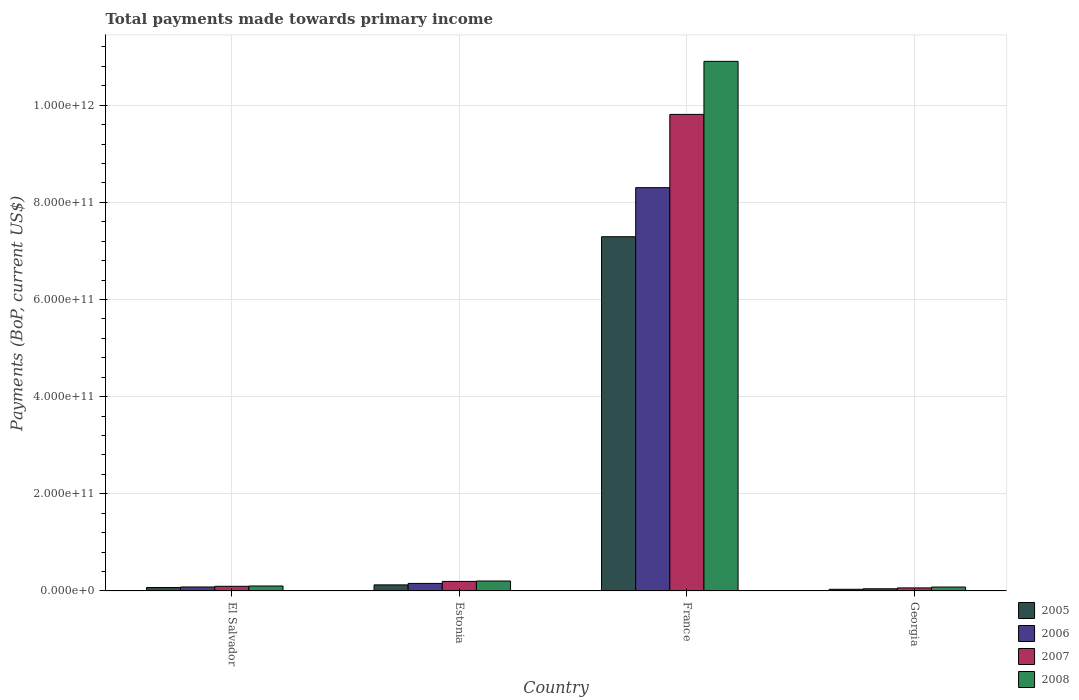How many bars are there on the 1st tick from the left?
Provide a succinct answer. 4. How many bars are there on the 3rd tick from the right?
Ensure brevity in your answer.  4. What is the label of the 4th group of bars from the left?
Your answer should be very brief. Georgia. In how many cases, is the number of bars for a given country not equal to the number of legend labels?
Offer a terse response. 0. What is the total payments made towards primary income in 2007 in France?
Your response must be concise. 9.81e+11. Across all countries, what is the maximum total payments made towards primary income in 2007?
Provide a short and direct response. 9.81e+11. Across all countries, what is the minimum total payments made towards primary income in 2008?
Give a very brief answer. 8.11e+09. In which country was the total payments made towards primary income in 2007 minimum?
Give a very brief answer. Georgia. What is the total total payments made towards primary income in 2006 in the graph?
Your response must be concise. 8.59e+11. What is the difference between the total payments made towards primary income in 2008 in El Salvador and that in Georgia?
Your answer should be compact. 2.15e+09. What is the difference between the total payments made towards primary income in 2005 in Estonia and the total payments made towards primary income in 2007 in El Salvador?
Ensure brevity in your answer.  2.93e+09. What is the average total payments made towards primary income in 2006 per country?
Your answer should be very brief. 2.15e+11. What is the difference between the total payments made towards primary income of/in 2007 and total payments made towards primary income of/in 2006 in Estonia?
Ensure brevity in your answer.  4.11e+09. What is the ratio of the total payments made towards primary income in 2006 in El Salvador to that in Georgia?
Provide a succinct answer. 1.81. Is the total payments made towards primary income in 2005 in Estonia less than that in Georgia?
Provide a succinct answer. No. What is the difference between the highest and the second highest total payments made towards primary income in 2008?
Keep it short and to the point. 1.07e+12. What is the difference between the highest and the lowest total payments made towards primary income in 2005?
Give a very brief answer. 7.26e+11. In how many countries, is the total payments made towards primary income in 2008 greater than the average total payments made towards primary income in 2008 taken over all countries?
Provide a short and direct response. 1. What does the 2nd bar from the left in Estonia represents?
Your answer should be very brief. 2006. Is it the case that in every country, the sum of the total payments made towards primary income in 2005 and total payments made towards primary income in 2007 is greater than the total payments made towards primary income in 2006?
Your answer should be compact. Yes. How many bars are there?
Make the answer very short. 16. Are all the bars in the graph horizontal?
Make the answer very short. No. What is the difference between two consecutive major ticks on the Y-axis?
Offer a very short reply. 2.00e+11. Are the values on the major ticks of Y-axis written in scientific E-notation?
Your answer should be very brief. Yes. Does the graph contain any zero values?
Your answer should be compact. No. Does the graph contain grids?
Offer a terse response. Yes. Where does the legend appear in the graph?
Keep it short and to the point. Bottom right. How many legend labels are there?
Make the answer very short. 4. How are the legend labels stacked?
Offer a terse response. Vertical. What is the title of the graph?
Keep it short and to the point. Total payments made towards primary income. What is the label or title of the Y-axis?
Provide a succinct answer. Payments (BoP, current US$). What is the Payments (BoP, current US$) of 2005 in El Salvador?
Provide a succinct answer. 7.17e+09. What is the Payments (BoP, current US$) in 2006 in El Salvador?
Give a very brief answer. 8.24e+09. What is the Payments (BoP, current US$) in 2007 in El Salvador?
Provide a short and direct response. 9.62e+09. What is the Payments (BoP, current US$) of 2008 in El Salvador?
Offer a very short reply. 1.03e+1. What is the Payments (BoP, current US$) in 2005 in Estonia?
Offer a very short reply. 1.25e+1. What is the Payments (BoP, current US$) of 2006 in Estonia?
Make the answer very short. 1.56e+1. What is the Payments (BoP, current US$) of 2007 in Estonia?
Your answer should be very brief. 1.97e+1. What is the Payments (BoP, current US$) in 2008 in Estonia?
Offer a very short reply. 2.05e+1. What is the Payments (BoP, current US$) in 2005 in France?
Keep it short and to the point. 7.29e+11. What is the Payments (BoP, current US$) of 2006 in France?
Offer a terse response. 8.30e+11. What is the Payments (BoP, current US$) of 2007 in France?
Your response must be concise. 9.81e+11. What is the Payments (BoP, current US$) of 2008 in France?
Provide a succinct answer. 1.09e+12. What is the Payments (BoP, current US$) of 2005 in Georgia?
Your answer should be very brief. 3.47e+09. What is the Payments (BoP, current US$) in 2006 in Georgia?
Make the answer very short. 4.56e+09. What is the Payments (BoP, current US$) of 2007 in Georgia?
Your answer should be very brief. 6.32e+09. What is the Payments (BoP, current US$) of 2008 in Georgia?
Offer a very short reply. 8.11e+09. Across all countries, what is the maximum Payments (BoP, current US$) of 2005?
Make the answer very short. 7.29e+11. Across all countries, what is the maximum Payments (BoP, current US$) of 2006?
Offer a very short reply. 8.30e+11. Across all countries, what is the maximum Payments (BoP, current US$) in 2007?
Ensure brevity in your answer.  9.81e+11. Across all countries, what is the maximum Payments (BoP, current US$) of 2008?
Make the answer very short. 1.09e+12. Across all countries, what is the minimum Payments (BoP, current US$) of 2005?
Your response must be concise. 3.47e+09. Across all countries, what is the minimum Payments (BoP, current US$) in 2006?
Your response must be concise. 4.56e+09. Across all countries, what is the minimum Payments (BoP, current US$) of 2007?
Make the answer very short. 6.32e+09. Across all countries, what is the minimum Payments (BoP, current US$) in 2008?
Ensure brevity in your answer.  8.11e+09. What is the total Payments (BoP, current US$) of 2005 in the graph?
Your response must be concise. 7.53e+11. What is the total Payments (BoP, current US$) of 2006 in the graph?
Your response must be concise. 8.59e+11. What is the total Payments (BoP, current US$) of 2007 in the graph?
Give a very brief answer. 1.02e+12. What is the total Payments (BoP, current US$) of 2008 in the graph?
Offer a terse response. 1.13e+12. What is the difference between the Payments (BoP, current US$) of 2005 in El Salvador and that in Estonia?
Your answer should be compact. -5.38e+09. What is the difference between the Payments (BoP, current US$) in 2006 in El Salvador and that in Estonia?
Ensure brevity in your answer.  -7.33e+09. What is the difference between the Payments (BoP, current US$) in 2007 in El Salvador and that in Estonia?
Your answer should be compact. -1.01e+1. What is the difference between the Payments (BoP, current US$) of 2008 in El Salvador and that in Estonia?
Your answer should be very brief. -1.03e+1. What is the difference between the Payments (BoP, current US$) of 2005 in El Salvador and that in France?
Offer a terse response. -7.22e+11. What is the difference between the Payments (BoP, current US$) in 2006 in El Salvador and that in France?
Your answer should be compact. -8.22e+11. What is the difference between the Payments (BoP, current US$) in 2007 in El Salvador and that in France?
Provide a short and direct response. -9.72e+11. What is the difference between the Payments (BoP, current US$) of 2008 in El Salvador and that in France?
Offer a terse response. -1.08e+12. What is the difference between the Payments (BoP, current US$) of 2005 in El Salvador and that in Georgia?
Offer a very short reply. 3.70e+09. What is the difference between the Payments (BoP, current US$) in 2006 in El Salvador and that in Georgia?
Make the answer very short. 3.69e+09. What is the difference between the Payments (BoP, current US$) of 2007 in El Salvador and that in Georgia?
Offer a terse response. 3.29e+09. What is the difference between the Payments (BoP, current US$) in 2008 in El Salvador and that in Georgia?
Provide a succinct answer. 2.15e+09. What is the difference between the Payments (BoP, current US$) in 2005 in Estonia and that in France?
Provide a short and direct response. -7.17e+11. What is the difference between the Payments (BoP, current US$) of 2006 in Estonia and that in France?
Your answer should be compact. -8.15e+11. What is the difference between the Payments (BoP, current US$) in 2007 in Estonia and that in France?
Provide a short and direct response. -9.61e+11. What is the difference between the Payments (BoP, current US$) of 2008 in Estonia and that in France?
Your answer should be compact. -1.07e+12. What is the difference between the Payments (BoP, current US$) of 2005 in Estonia and that in Georgia?
Your answer should be compact. 9.08e+09. What is the difference between the Payments (BoP, current US$) in 2006 in Estonia and that in Georgia?
Make the answer very short. 1.10e+1. What is the difference between the Payments (BoP, current US$) of 2007 in Estonia and that in Georgia?
Make the answer very short. 1.34e+1. What is the difference between the Payments (BoP, current US$) in 2008 in Estonia and that in Georgia?
Your answer should be very brief. 1.24e+1. What is the difference between the Payments (BoP, current US$) of 2005 in France and that in Georgia?
Give a very brief answer. 7.26e+11. What is the difference between the Payments (BoP, current US$) in 2006 in France and that in Georgia?
Your answer should be very brief. 8.26e+11. What is the difference between the Payments (BoP, current US$) of 2007 in France and that in Georgia?
Your answer should be compact. 9.75e+11. What is the difference between the Payments (BoP, current US$) in 2008 in France and that in Georgia?
Ensure brevity in your answer.  1.08e+12. What is the difference between the Payments (BoP, current US$) of 2005 in El Salvador and the Payments (BoP, current US$) of 2006 in Estonia?
Keep it short and to the point. -8.40e+09. What is the difference between the Payments (BoP, current US$) of 2005 in El Salvador and the Payments (BoP, current US$) of 2007 in Estonia?
Make the answer very short. -1.25e+1. What is the difference between the Payments (BoP, current US$) of 2005 in El Salvador and the Payments (BoP, current US$) of 2008 in Estonia?
Make the answer very short. -1.34e+1. What is the difference between the Payments (BoP, current US$) in 2006 in El Salvador and the Payments (BoP, current US$) in 2007 in Estonia?
Offer a very short reply. -1.14e+1. What is the difference between the Payments (BoP, current US$) of 2006 in El Salvador and the Payments (BoP, current US$) of 2008 in Estonia?
Offer a terse response. -1.23e+1. What is the difference between the Payments (BoP, current US$) of 2007 in El Salvador and the Payments (BoP, current US$) of 2008 in Estonia?
Make the answer very short. -1.09e+1. What is the difference between the Payments (BoP, current US$) of 2005 in El Salvador and the Payments (BoP, current US$) of 2006 in France?
Give a very brief answer. -8.23e+11. What is the difference between the Payments (BoP, current US$) in 2005 in El Salvador and the Payments (BoP, current US$) in 2007 in France?
Ensure brevity in your answer.  -9.74e+11. What is the difference between the Payments (BoP, current US$) in 2005 in El Salvador and the Payments (BoP, current US$) in 2008 in France?
Offer a very short reply. -1.08e+12. What is the difference between the Payments (BoP, current US$) of 2006 in El Salvador and the Payments (BoP, current US$) of 2007 in France?
Give a very brief answer. -9.73e+11. What is the difference between the Payments (BoP, current US$) of 2006 in El Salvador and the Payments (BoP, current US$) of 2008 in France?
Keep it short and to the point. -1.08e+12. What is the difference between the Payments (BoP, current US$) in 2007 in El Salvador and the Payments (BoP, current US$) in 2008 in France?
Keep it short and to the point. -1.08e+12. What is the difference between the Payments (BoP, current US$) in 2005 in El Salvador and the Payments (BoP, current US$) in 2006 in Georgia?
Provide a short and direct response. 2.62e+09. What is the difference between the Payments (BoP, current US$) of 2005 in El Salvador and the Payments (BoP, current US$) of 2007 in Georgia?
Ensure brevity in your answer.  8.48e+08. What is the difference between the Payments (BoP, current US$) of 2005 in El Salvador and the Payments (BoP, current US$) of 2008 in Georgia?
Offer a very short reply. -9.42e+08. What is the difference between the Payments (BoP, current US$) in 2006 in El Salvador and the Payments (BoP, current US$) in 2007 in Georgia?
Provide a succinct answer. 1.92e+09. What is the difference between the Payments (BoP, current US$) in 2006 in El Salvador and the Payments (BoP, current US$) in 2008 in Georgia?
Give a very brief answer. 1.28e+08. What is the difference between the Payments (BoP, current US$) in 2007 in El Salvador and the Payments (BoP, current US$) in 2008 in Georgia?
Keep it short and to the point. 1.50e+09. What is the difference between the Payments (BoP, current US$) of 2005 in Estonia and the Payments (BoP, current US$) of 2006 in France?
Offer a terse response. -8.18e+11. What is the difference between the Payments (BoP, current US$) of 2005 in Estonia and the Payments (BoP, current US$) of 2007 in France?
Your answer should be very brief. -9.69e+11. What is the difference between the Payments (BoP, current US$) in 2005 in Estonia and the Payments (BoP, current US$) in 2008 in France?
Your response must be concise. -1.08e+12. What is the difference between the Payments (BoP, current US$) of 2006 in Estonia and the Payments (BoP, current US$) of 2007 in France?
Provide a short and direct response. -9.66e+11. What is the difference between the Payments (BoP, current US$) of 2006 in Estonia and the Payments (BoP, current US$) of 2008 in France?
Keep it short and to the point. -1.07e+12. What is the difference between the Payments (BoP, current US$) of 2007 in Estonia and the Payments (BoP, current US$) of 2008 in France?
Provide a succinct answer. -1.07e+12. What is the difference between the Payments (BoP, current US$) in 2005 in Estonia and the Payments (BoP, current US$) in 2006 in Georgia?
Offer a very short reply. 7.99e+09. What is the difference between the Payments (BoP, current US$) in 2005 in Estonia and the Payments (BoP, current US$) in 2007 in Georgia?
Make the answer very short. 6.22e+09. What is the difference between the Payments (BoP, current US$) in 2005 in Estonia and the Payments (BoP, current US$) in 2008 in Georgia?
Make the answer very short. 4.43e+09. What is the difference between the Payments (BoP, current US$) of 2006 in Estonia and the Payments (BoP, current US$) of 2007 in Georgia?
Provide a short and direct response. 9.25e+09. What is the difference between the Payments (BoP, current US$) in 2006 in Estonia and the Payments (BoP, current US$) in 2008 in Georgia?
Offer a very short reply. 7.46e+09. What is the difference between the Payments (BoP, current US$) of 2007 in Estonia and the Payments (BoP, current US$) of 2008 in Georgia?
Your response must be concise. 1.16e+1. What is the difference between the Payments (BoP, current US$) in 2005 in France and the Payments (BoP, current US$) in 2006 in Georgia?
Your response must be concise. 7.25e+11. What is the difference between the Payments (BoP, current US$) of 2005 in France and the Payments (BoP, current US$) of 2007 in Georgia?
Keep it short and to the point. 7.23e+11. What is the difference between the Payments (BoP, current US$) in 2005 in France and the Payments (BoP, current US$) in 2008 in Georgia?
Provide a succinct answer. 7.21e+11. What is the difference between the Payments (BoP, current US$) of 2006 in France and the Payments (BoP, current US$) of 2007 in Georgia?
Your response must be concise. 8.24e+11. What is the difference between the Payments (BoP, current US$) in 2006 in France and the Payments (BoP, current US$) in 2008 in Georgia?
Your response must be concise. 8.22e+11. What is the difference between the Payments (BoP, current US$) in 2007 in France and the Payments (BoP, current US$) in 2008 in Georgia?
Make the answer very short. 9.73e+11. What is the average Payments (BoP, current US$) in 2005 per country?
Your response must be concise. 1.88e+11. What is the average Payments (BoP, current US$) in 2006 per country?
Provide a short and direct response. 2.15e+11. What is the average Payments (BoP, current US$) of 2007 per country?
Give a very brief answer. 2.54e+11. What is the average Payments (BoP, current US$) of 2008 per country?
Give a very brief answer. 2.82e+11. What is the difference between the Payments (BoP, current US$) of 2005 and Payments (BoP, current US$) of 2006 in El Salvador?
Give a very brief answer. -1.07e+09. What is the difference between the Payments (BoP, current US$) in 2005 and Payments (BoP, current US$) in 2007 in El Salvador?
Keep it short and to the point. -2.45e+09. What is the difference between the Payments (BoP, current US$) of 2005 and Payments (BoP, current US$) of 2008 in El Salvador?
Your answer should be compact. -3.09e+09. What is the difference between the Payments (BoP, current US$) in 2006 and Payments (BoP, current US$) in 2007 in El Salvador?
Your response must be concise. -1.38e+09. What is the difference between the Payments (BoP, current US$) in 2006 and Payments (BoP, current US$) in 2008 in El Salvador?
Offer a very short reply. -2.03e+09. What is the difference between the Payments (BoP, current US$) in 2007 and Payments (BoP, current US$) in 2008 in El Salvador?
Your response must be concise. -6.48e+08. What is the difference between the Payments (BoP, current US$) in 2005 and Payments (BoP, current US$) in 2006 in Estonia?
Your answer should be compact. -3.02e+09. What is the difference between the Payments (BoP, current US$) in 2005 and Payments (BoP, current US$) in 2007 in Estonia?
Provide a short and direct response. -7.14e+09. What is the difference between the Payments (BoP, current US$) of 2005 and Payments (BoP, current US$) of 2008 in Estonia?
Your response must be concise. -7.98e+09. What is the difference between the Payments (BoP, current US$) in 2006 and Payments (BoP, current US$) in 2007 in Estonia?
Your response must be concise. -4.11e+09. What is the difference between the Payments (BoP, current US$) of 2006 and Payments (BoP, current US$) of 2008 in Estonia?
Provide a short and direct response. -4.96e+09. What is the difference between the Payments (BoP, current US$) of 2007 and Payments (BoP, current US$) of 2008 in Estonia?
Offer a very short reply. -8.45e+08. What is the difference between the Payments (BoP, current US$) of 2005 and Payments (BoP, current US$) of 2006 in France?
Your answer should be very brief. -1.01e+11. What is the difference between the Payments (BoP, current US$) in 2005 and Payments (BoP, current US$) in 2007 in France?
Your answer should be compact. -2.52e+11. What is the difference between the Payments (BoP, current US$) in 2005 and Payments (BoP, current US$) in 2008 in France?
Make the answer very short. -3.61e+11. What is the difference between the Payments (BoP, current US$) in 2006 and Payments (BoP, current US$) in 2007 in France?
Offer a very short reply. -1.51e+11. What is the difference between the Payments (BoP, current US$) in 2006 and Payments (BoP, current US$) in 2008 in France?
Provide a short and direct response. -2.60e+11. What is the difference between the Payments (BoP, current US$) in 2007 and Payments (BoP, current US$) in 2008 in France?
Your answer should be very brief. -1.09e+11. What is the difference between the Payments (BoP, current US$) of 2005 and Payments (BoP, current US$) of 2006 in Georgia?
Provide a short and direct response. -1.09e+09. What is the difference between the Payments (BoP, current US$) in 2005 and Payments (BoP, current US$) in 2007 in Georgia?
Provide a short and direct response. -2.86e+09. What is the difference between the Payments (BoP, current US$) of 2005 and Payments (BoP, current US$) of 2008 in Georgia?
Your answer should be compact. -4.65e+09. What is the difference between the Payments (BoP, current US$) in 2006 and Payments (BoP, current US$) in 2007 in Georgia?
Offer a terse response. -1.77e+09. What is the difference between the Payments (BoP, current US$) of 2006 and Payments (BoP, current US$) of 2008 in Georgia?
Offer a very short reply. -3.56e+09. What is the difference between the Payments (BoP, current US$) in 2007 and Payments (BoP, current US$) in 2008 in Georgia?
Ensure brevity in your answer.  -1.79e+09. What is the ratio of the Payments (BoP, current US$) in 2005 in El Salvador to that in Estonia?
Keep it short and to the point. 0.57. What is the ratio of the Payments (BoP, current US$) of 2006 in El Salvador to that in Estonia?
Provide a short and direct response. 0.53. What is the ratio of the Payments (BoP, current US$) of 2007 in El Salvador to that in Estonia?
Your answer should be very brief. 0.49. What is the ratio of the Payments (BoP, current US$) in 2008 in El Salvador to that in Estonia?
Provide a succinct answer. 0.5. What is the ratio of the Payments (BoP, current US$) in 2005 in El Salvador to that in France?
Provide a succinct answer. 0.01. What is the ratio of the Payments (BoP, current US$) in 2006 in El Salvador to that in France?
Make the answer very short. 0.01. What is the ratio of the Payments (BoP, current US$) in 2007 in El Salvador to that in France?
Your answer should be compact. 0.01. What is the ratio of the Payments (BoP, current US$) of 2008 in El Salvador to that in France?
Provide a succinct answer. 0.01. What is the ratio of the Payments (BoP, current US$) in 2005 in El Salvador to that in Georgia?
Keep it short and to the point. 2.07. What is the ratio of the Payments (BoP, current US$) of 2006 in El Salvador to that in Georgia?
Offer a terse response. 1.81. What is the ratio of the Payments (BoP, current US$) of 2007 in El Salvador to that in Georgia?
Provide a succinct answer. 1.52. What is the ratio of the Payments (BoP, current US$) of 2008 in El Salvador to that in Georgia?
Provide a short and direct response. 1.27. What is the ratio of the Payments (BoP, current US$) of 2005 in Estonia to that in France?
Offer a very short reply. 0.02. What is the ratio of the Payments (BoP, current US$) of 2006 in Estonia to that in France?
Keep it short and to the point. 0.02. What is the ratio of the Payments (BoP, current US$) of 2007 in Estonia to that in France?
Provide a succinct answer. 0.02. What is the ratio of the Payments (BoP, current US$) in 2008 in Estonia to that in France?
Ensure brevity in your answer.  0.02. What is the ratio of the Payments (BoP, current US$) of 2005 in Estonia to that in Georgia?
Ensure brevity in your answer.  3.62. What is the ratio of the Payments (BoP, current US$) in 2006 in Estonia to that in Georgia?
Offer a very short reply. 3.42. What is the ratio of the Payments (BoP, current US$) in 2007 in Estonia to that in Georgia?
Offer a terse response. 3.11. What is the ratio of the Payments (BoP, current US$) of 2008 in Estonia to that in Georgia?
Provide a short and direct response. 2.53. What is the ratio of the Payments (BoP, current US$) of 2005 in France to that in Georgia?
Ensure brevity in your answer.  210.24. What is the ratio of the Payments (BoP, current US$) of 2006 in France to that in Georgia?
Offer a terse response. 182.27. What is the ratio of the Payments (BoP, current US$) of 2007 in France to that in Georgia?
Offer a terse response. 155.13. What is the ratio of the Payments (BoP, current US$) in 2008 in France to that in Georgia?
Give a very brief answer. 134.37. What is the difference between the highest and the second highest Payments (BoP, current US$) of 2005?
Offer a terse response. 7.17e+11. What is the difference between the highest and the second highest Payments (BoP, current US$) of 2006?
Give a very brief answer. 8.15e+11. What is the difference between the highest and the second highest Payments (BoP, current US$) of 2007?
Your answer should be compact. 9.61e+11. What is the difference between the highest and the second highest Payments (BoP, current US$) of 2008?
Give a very brief answer. 1.07e+12. What is the difference between the highest and the lowest Payments (BoP, current US$) of 2005?
Offer a very short reply. 7.26e+11. What is the difference between the highest and the lowest Payments (BoP, current US$) of 2006?
Your response must be concise. 8.26e+11. What is the difference between the highest and the lowest Payments (BoP, current US$) of 2007?
Ensure brevity in your answer.  9.75e+11. What is the difference between the highest and the lowest Payments (BoP, current US$) of 2008?
Make the answer very short. 1.08e+12. 